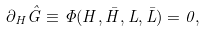Convert formula to latex. <formula><loc_0><loc_0><loc_500><loc_500>\partial _ { H } \hat { G } \equiv \Phi ( H , \bar { H } , L , \bar { L } ) = 0 ,</formula> 